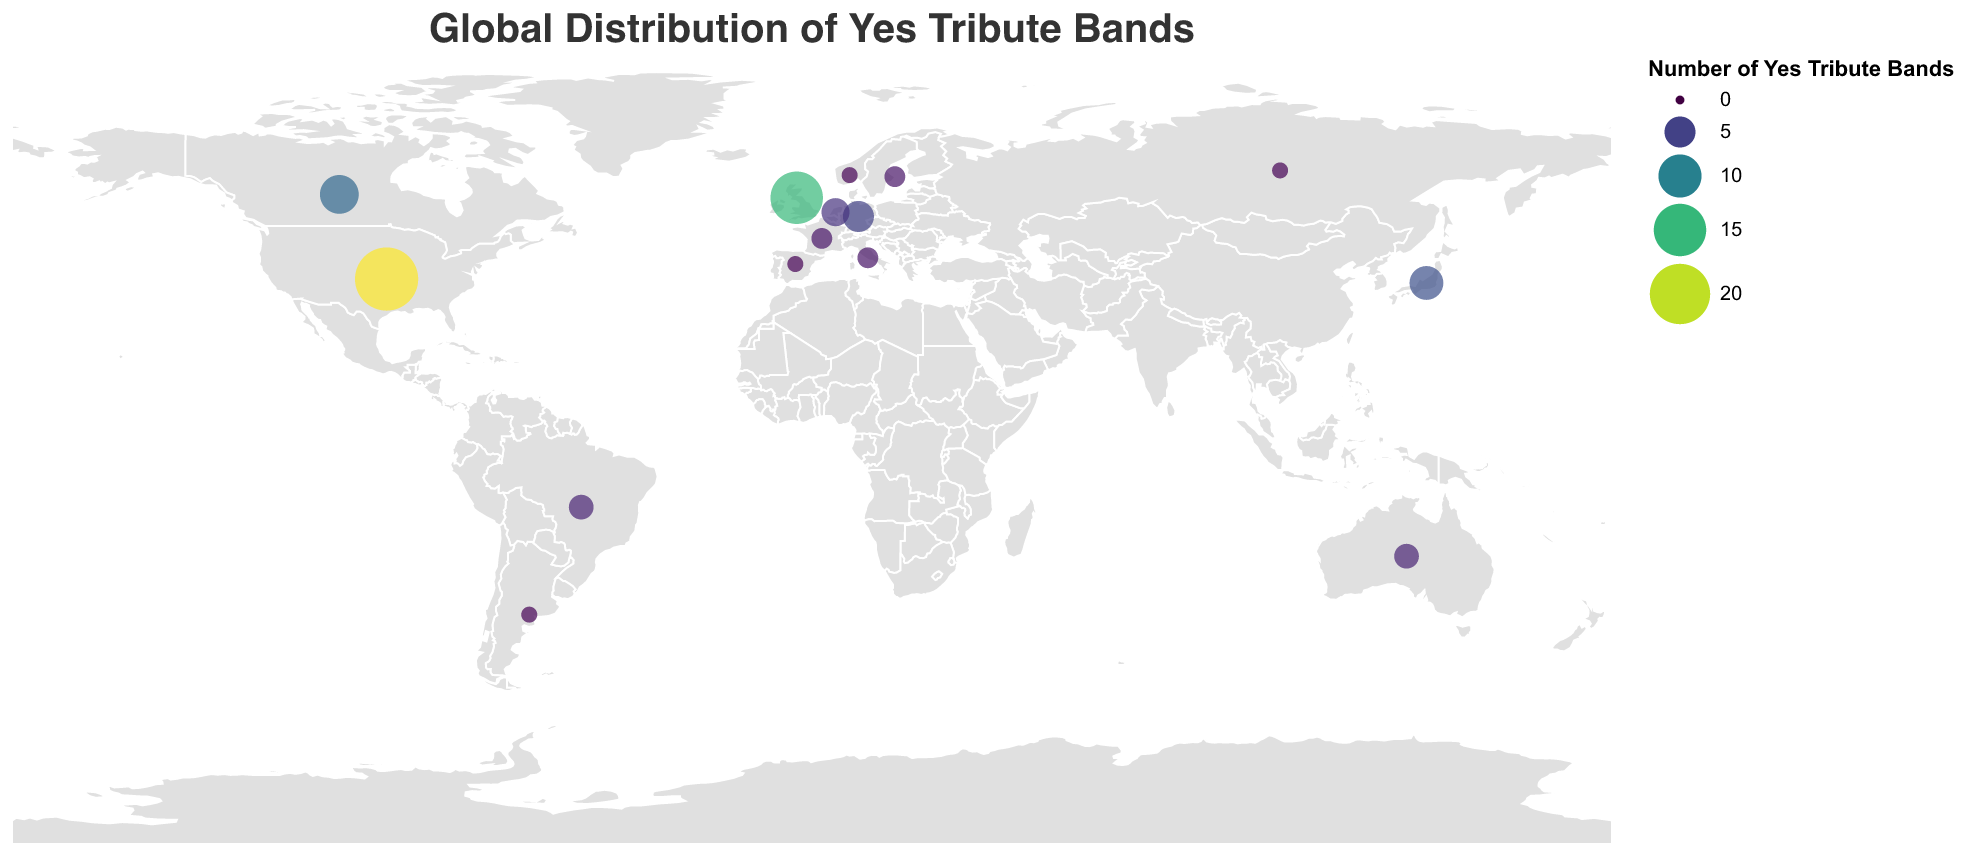What is the title of the figure? The title can be found at the top of the figure and is clearly visible in a larger font.
Answer: Global Distribution of Yes Tribute Bands Which country has the highest number of Yes tribute bands? To find this, we look for the largest circle and check the associated tooltip for the country and the number of bands.
Answer: United States How many Yes tribute bands are there in total in the United Kingdom and the United States? Add the number of Yes tribute bands in the United Kingdom (15) and the United States (22): 15 + 22 = 37
Answer: 37 Which country in Europe has the fewest Yes tribute bands? Looking at European countries on the map and referencing the number of bands, Norway, Spain, and Argentina each have 1 band. Each is a country with the fewest bands.
Answer: Norway What is the approximate latitude and longitude for Yes tribute bands in Japan? Locate Japan on the map and hover over the circle to find the latitude and longitude in the tooltip.
Answer: 36.2048, 138.2529 Which two countries have the same number of Yes tribute bands, and what is that number? By examining the sizes of the circles and the tooltips, you can find that Sweden and France both have 2 Yes tribute bands.
Answer: Sweden and France, 2 How many countries have exactly 1 Yes tribute band? Count the number of countries with circles representing exactly 1 Yes tribute band.
Answer: 5 What is the total number of Yes tribute bands in the dataset? Sum all the values from each country: 15 + 22 + 8 + 6 + 5 + 4 + 3 + 3 + 2 + 2 + 2 + 1 + 1 + 1 + 1 = 76
Answer: 76 Which continents have representation of Yes tribute bands in the figure, and how many continents are those? Identify represented continents by examining the locations: North America, South America, Europe, Asia, Australia. There are 5 continents in total.
Answer: 5 What is the average number of Yes tribute bands per country? Divide the total number of Yes tribute bands by the number of countries: 76 bands / 15 countries = 5.07 (approximately)
Answer: 5.07 